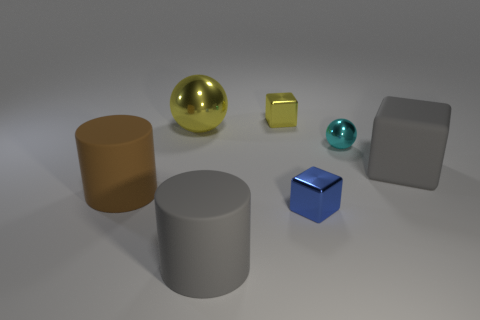How many shiny objects are either big gray cubes or gray objects? In the image, while several objects exhibit a degree of shininess, none of the objects can be classified as big gray cubes. There is one large gray cylinder and one large gray cube that could be described as shiny due to their reflective surfaces. If we consider 'gray objects' as a broader category, which includes any object with a gray color, there are two shiny gray objects in total. 